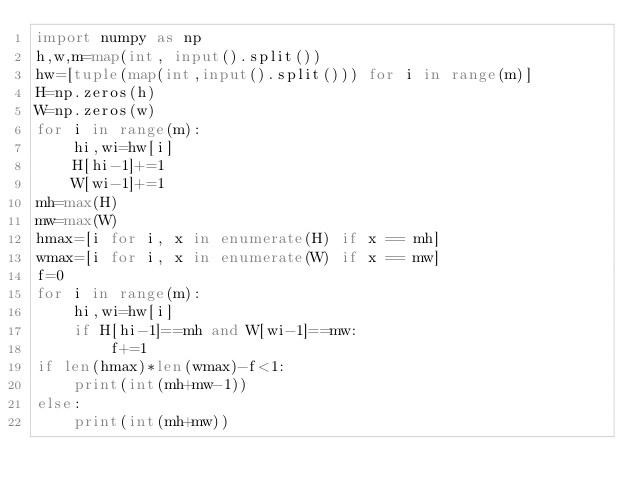<code> <loc_0><loc_0><loc_500><loc_500><_Python_>import numpy as np
h,w,m=map(int, input().split())
hw=[tuple(map(int,input().split())) for i in range(m)]
H=np.zeros(h)
W=np.zeros(w)
for i in range(m):
    hi,wi=hw[i]
    H[hi-1]+=1
    W[wi-1]+=1
mh=max(H)
mw=max(W)
hmax=[i for i, x in enumerate(H) if x == mh]
wmax=[i for i, x in enumerate(W) if x == mw]
f=0
for i in range(m):
    hi,wi=hw[i]
    if H[hi-1]==mh and W[wi-1]==mw:
        f+=1
if len(hmax)*len(wmax)-f<1:
    print(int(mh+mw-1))
else:
    print(int(mh+mw))</code> 